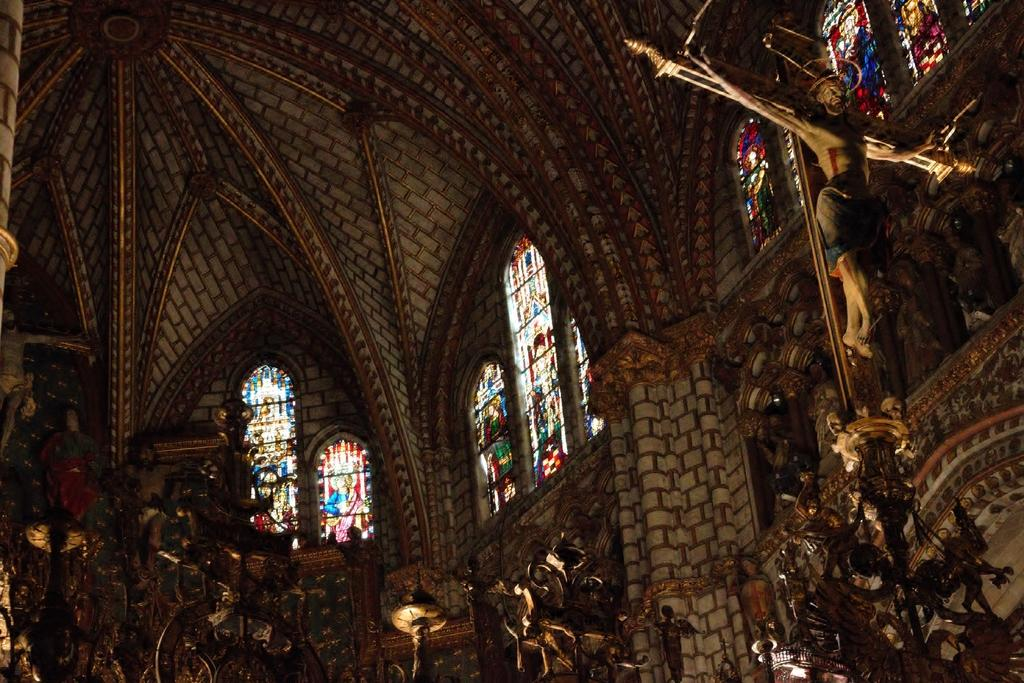What type of building is depicted in the image? There is a beautiful church in the image. Are there any objects or items related to the church in the image? Yes, there are glasses and statues in the image, presumably associated with the church. How much money is being exchanged between the pig and the tank in the image? There is no pig or tank present in the image, so this question cannot be answered. 